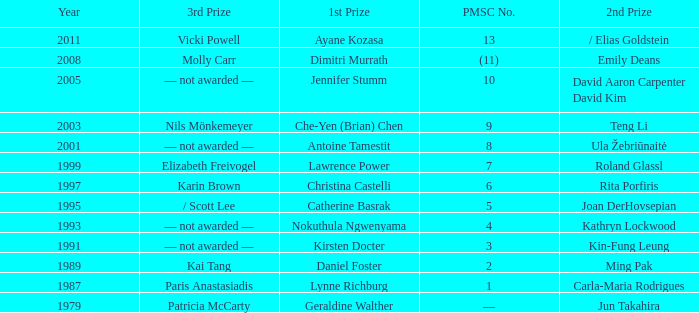What is the earliest year in which the 1st price went to Che-Yen (Brian) Chen? 2003.0. 